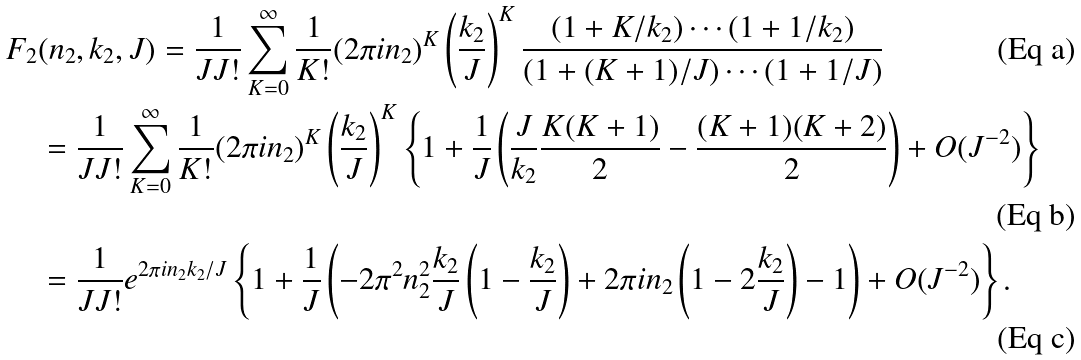Convert formula to latex. <formula><loc_0><loc_0><loc_500><loc_500>F _ { 2 } & ( n _ { 2 } , k _ { 2 } , J ) = \frac { 1 } { J J ! } \sum _ { K = 0 } ^ { \infty } \frac { 1 } { K ! } ( 2 \pi i n _ { 2 } ) ^ { K } \left ( \frac { k _ { 2 } } { J } \right ) ^ { K } \frac { ( 1 + K / k _ { 2 } ) \cdots ( 1 + 1 / k _ { 2 } ) } { ( 1 + ( K + 1 ) / J ) \cdots ( 1 + 1 / J ) } \\ & = \frac { 1 } { J J ! } \sum _ { K = 0 } ^ { \infty } \frac { 1 } { K ! } ( 2 \pi i n _ { 2 } ) ^ { K } \left ( \frac { k _ { 2 } } { J } \right ) ^ { K } \left \{ 1 + \frac { 1 } { J } \left ( \frac { J } { k _ { 2 } } \frac { K ( K + 1 ) } { 2 } - \frac { ( K + 1 ) ( K + 2 ) } { 2 } \right ) + O ( J ^ { - 2 } ) \right \} \\ & = \frac { 1 } { J J ! } e ^ { 2 \pi i n _ { 2 } k _ { 2 } / J } \left \{ 1 + \frac { 1 } { J } \left ( - 2 \pi ^ { 2 } n _ { 2 } ^ { 2 } \frac { k _ { 2 } } { J } \left ( 1 - \frac { k _ { 2 } } { J } \right ) + 2 \pi i n _ { 2 } \left ( 1 - 2 \frac { k _ { 2 } } { J } \right ) - 1 \right ) + O ( J ^ { - 2 } ) \right \} .</formula> 